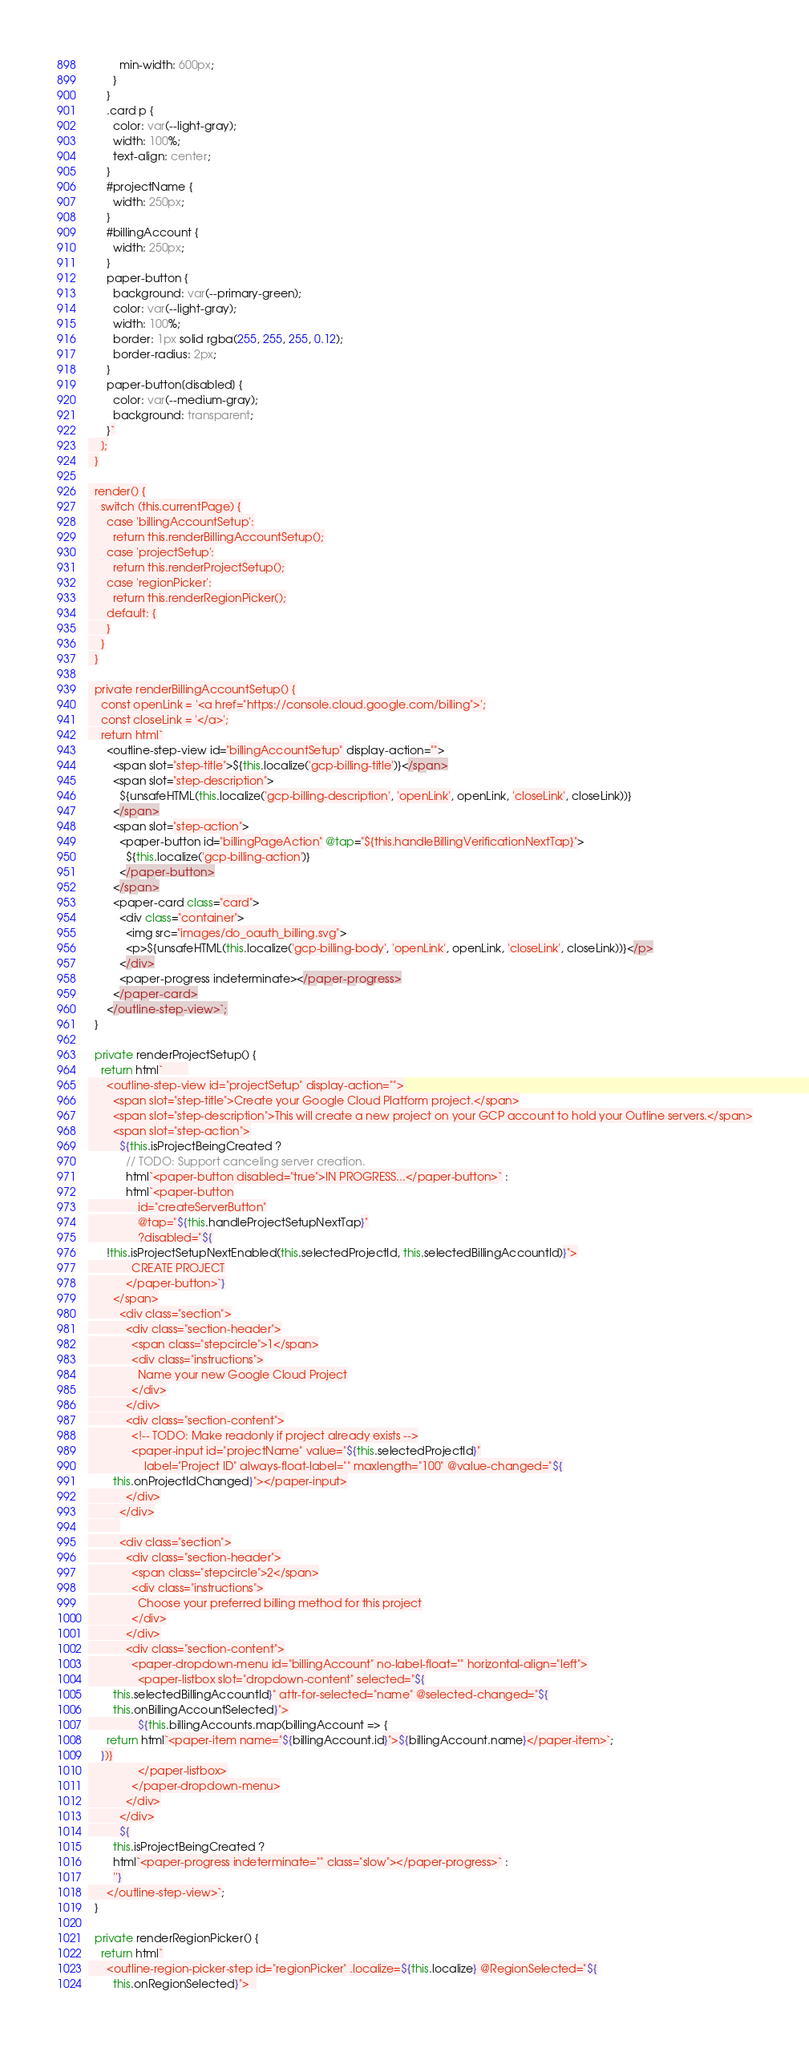Convert code to text. <code><loc_0><loc_0><loc_500><loc_500><_TypeScript_>          min-width: 600px;
        }
      }
      .card p {
        color: var(--light-gray);
        width: 100%;
        text-align: center;
      }
      #projectName {
        width: 250px;
      }
      #billingAccount {
        width: 250px;
      }
      paper-button {
        background: var(--primary-green);
        color: var(--light-gray);
        width: 100%;
        border: 1px solid rgba(255, 255, 255, 0.12);
        border-radius: 2px;
      }
      paper-button[disabled] {
        color: var(--medium-gray);
        background: transparent;
      }`
    ];
  }

  render() {
    switch (this.currentPage) {
      case 'billingAccountSetup':
        return this.renderBillingAccountSetup();
      case 'projectSetup':
        return this.renderProjectSetup();
      case 'regionPicker':
        return this.renderRegionPicker();
      default: {
      }
    }
  }

  private renderBillingAccountSetup() {
    const openLink = '<a href="https://console.cloud.google.com/billing">';
    const closeLink = '</a>';
    return html`
      <outline-step-view id="billingAccountSetup" display-action="">
        <span slot="step-title">${this.localize('gcp-billing-title')}</span>
        <span slot="step-description">
          ${unsafeHTML(this.localize('gcp-billing-description', 'openLink', openLink, 'closeLink', closeLink))}
        </span>
        <span slot="step-action">
          <paper-button id="billingPageAction" @tap="${this.handleBillingVerificationNextTap}">
            ${this.localize('gcp-billing-action')}
          </paper-button>
        </span>
        <paper-card class="card">
          <div class="container">
            <img src="images/do_oauth_billing.svg">
            <p>${unsafeHTML(this.localize('gcp-billing-body', 'openLink', openLink, 'closeLink', closeLink))}</p>
          </div>
          <paper-progress indeterminate></paper-progress>
        </paper-card>
      </outline-step-view>`;
  }

  private renderProjectSetup() {
    return html`        
      <outline-step-view id="projectSetup" display-action="">
        <span slot="step-title">Create your Google Cloud Platform project.</span>
        <span slot="step-description">This will create a new project on your GCP account to hold your Outline servers.</span>
        <span slot="step-action">
          ${this.isProjectBeingCreated ?
            // TODO: Support canceling server creation.
            html`<paper-button disabled="true">IN PROGRESS...</paper-button>` :
            html`<paper-button
                id="createServerButton"
                @tap="${this.handleProjectSetupNextTap}"
                ?disabled="${
      !this.isProjectSetupNextEnabled(this.selectedProjectId, this.selectedBillingAccountId)}">
              CREATE PROJECT
            </paper-button>`}
        </span>
          <div class="section">
            <div class="section-header">
              <span class="stepcircle">1</span>
              <div class="instructions">
                Name your new Google Cloud Project
              </div>
            </div>
            <div class="section-content">
              <!-- TODO: Make readonly if project already exists -->
              <paper-input id="projectName" value="${this.selectedProjectId}"
                  label="Project ID" always-float-label="" maxlength="100" @value-changed="${
        this.onProjectIdChanged}"></paper-input>
            </div>
          </div>
          
          <div class="section">
            <div class="section-header">
              <span class="stepcircle">2</span>
              <div class="instructions">
                Choose your preferred billing method for this project
              </div>
            </div>
            <div class="section-content">
              <paper-dropdown-menu id="billingAccount" no-label-float="" horizontal-align="left">
                <paper-listbox slot="dropdown-content" selected="${
        this.selectedBillingAccountId}" attr-for-selected="name" @selected-changed="${
        this.onBillingAccountSelected}">
                ${this.billingAccounts.map(billingAccount => {
      return html`<paper-item name="${billingAccount.id}">${billingAccount.name}</paper-item>`;
    })}
                </paper-listbox>
              </paper-dropdown-menu>
            </div>
          </div>
          ${
        this.isProjectBeingCreated ?
        html`<paper-progress indeterminate="" class="slow"></paper-progress>` :
        ''}
      </outline-step-view>`;
  }

  private renderRegionPicker() {
    return html`
      <outline-region-picker-step id="regionPicker" .localize=${this.localize} @RegionSelected="${
        this.onRegionSelected}">  </code> 